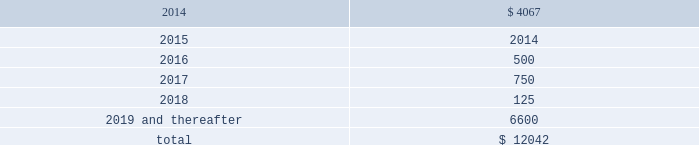Devon energy corporation and subsidiaries notes to consolidated financial statements 2013 ( continued ) debt maturities as of december 31 , 2013 , excluding premiums and discounts , are as follows ( in millions ) : .
Credit lines devon has a $ 3.0 billion syndicated , unsecured revolving line of credit ( the 201csenior credit facility 201d ) that matures on october 24 , 2018 .
However , prior to the maturity date , devon has the option to extend the maturity for up to one additional one-year period , subject to the approval of the lenders .
Amounts borrowed under the senior credit facility may , at the election of devon , bear interest at various fixed rate options for periods of up to twelve months .
Such rates are generally less than the prime rate .
However , devon may elect to borrow at the prime rate .
The senior credit facility currently provides for an annual facility fee of $ 3.8 million that is payable quarterly in arrears .
As of december 31 , 2013 , there were no borrowings under the senior credit facility .
The senior credit facility contains only one material financial covenant .
This covenant requires devon 2019s ratio of total funded debt to total capitalization , as defined in the credit agreement , to be no greater than 65 percent .
The credit agreement contains definitions of total funded debt and total capitalization that include adjustments to the respective amounts reported in the accompanying financial statements .
Also , total capitalization is adjusted to add back noncash financial write-downs such as full cost ceiling impairments or goodwill impairments .
As of december 31 , 2013 , devon was in compliance with this covenant with a debt-to- capitalization ratio of 25.7 percent .
Commercial paper devon has access to $ 3.0 billion of short-term credit under its commercial paper program .
Commercial paper debt generally has a maturity of between 1 and 90 days , although it can have a maturity of up to 365 days , and bears interest at rates agreed to at the time of the borrowing .
The interest rate is generally based on a standard index such as the federal funds rate , libor , or the money market rate as found in the commercial paper market .
As of december 31 , 2013 , devon 2019s weighted average borrowing rate on its commercial paper borrowings was 0.30 percent .
Other debentures and notes following are descriptions of the various other debentures and notes outstanding at december 31 , 2013 , as listed in the table presented at the beginning of this note .
Geosouthern debt in december 2013 , in conjunction with the planned geosouthern acquisition , devon issued $ 2.25 billion aggregate principal amount of fixed and floating rate senior notes resulting in cash proceeds of approximately .
What percentage of total debt maturities are from 2016 and 2017? 
Computations: (((500 + 750) / 12042) * 100)
Answer: 10.38034. 